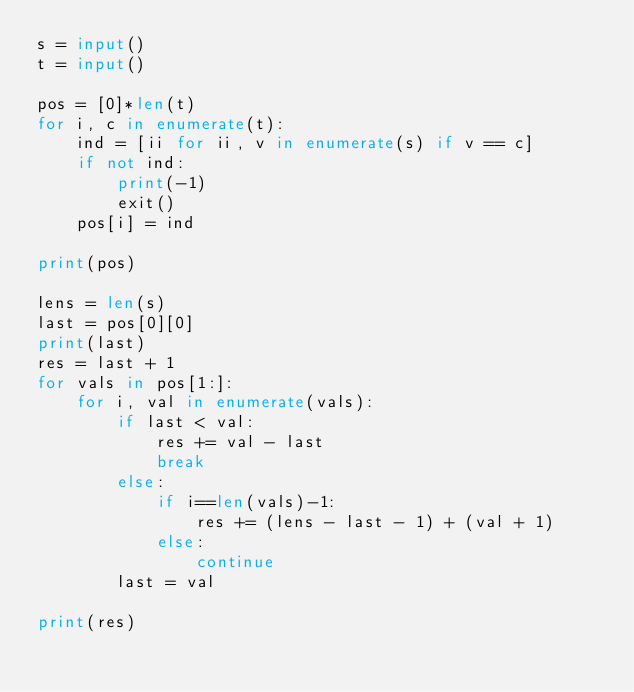<code> <loc_0><loc_0><loc_500><loc_500><_Python_>s = input()
t = input()

pos = [0]*len(t)
for i, c in enumerate(t):
    ind = [ii for ii, v in enumerate(s) if v == c]
    if not ind:
        print(-1)
        exit()
    pos[i] = ind

print(pos)

lens = len(s)
last = pos[0][0]
print(last)
res = last + 1
for vals in pos[1:]:
    for i, val in enumerate(vals):
        if last < val:
            res += val - last
            break
        else:
            if i==len(vals)-1:
                res += (lens - last - 1) + (val + 1)
            else:
                continue
        last = val

print(res)
</code> 